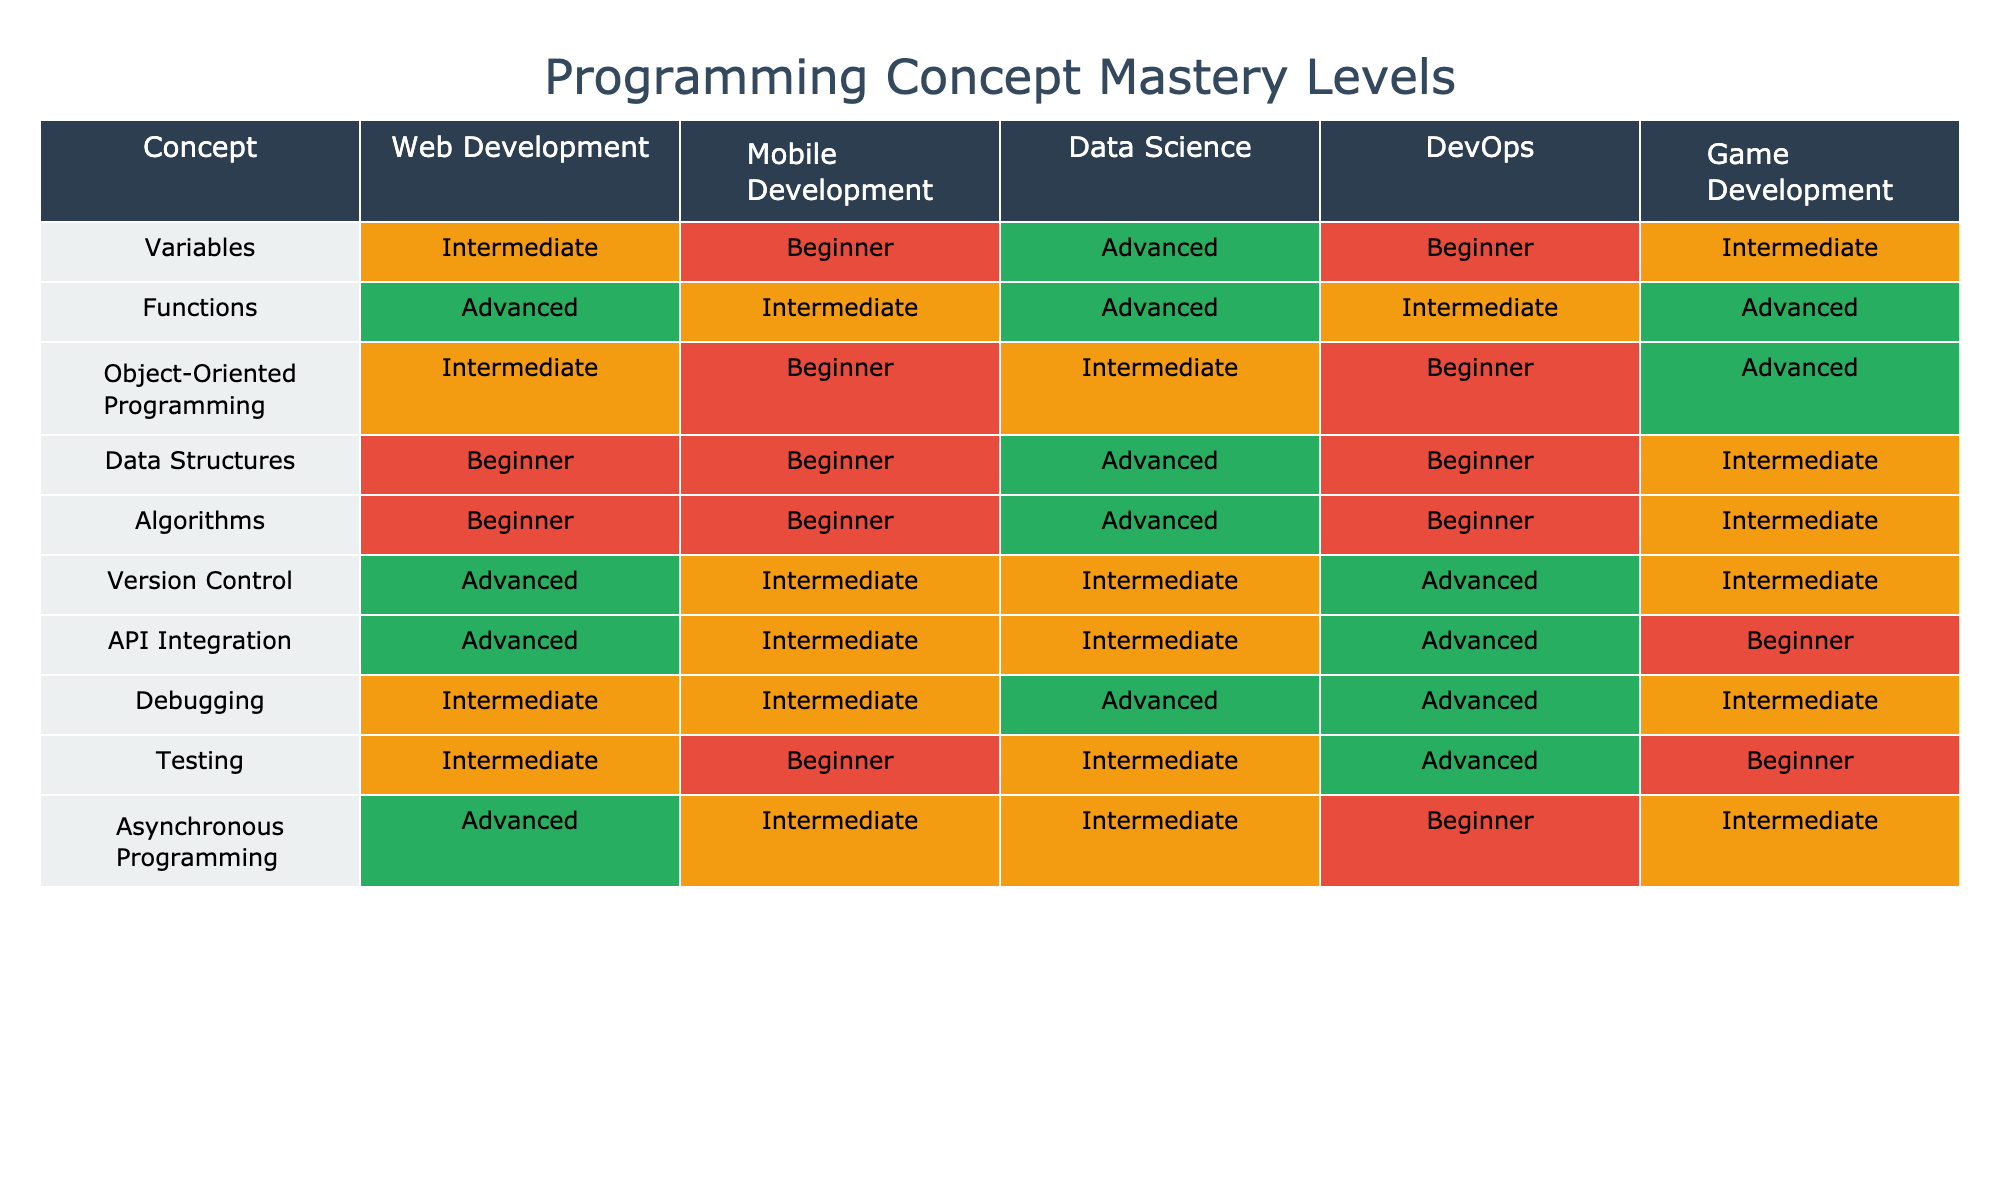What is the mastery level for Variables in Data Science? The table shows that for the "Variables" concept within the "Data Science" domain, the mastery level is "Advanced."
Answer: Advanced Which programming concept has the lowest mastery level in Mobile Development? By looking at the Mobile Development column, "Object-Oriented Programming," "Data Structures," and "Algorithms" are all rated as "Beginner," which is the lowest level.
Answer: Object-Oriented Programming, Data Structures, Algorithms How many concepts are rated as "Intermediate" in Game Development? In the Game Development row, I can count four occurrences of "Intermediate" in the concepts listed, specifically for Variables, Functions, Data Structures, and Debugging.
Answer: 4 Is API Integration rated higher in Web Development compared to DevOps? The table indicates that "API Integration" is rated as "Advanced" in Web Development and "Advanced" in DevOps as well, so they are equal.
Answer: Yes What is the average mastery level for Functions across all domains? Functions are rated as Advanced in Web Development, Intermediate in Mobile Development, Advanced in Data Science, Intermediate in DevOps, and Advanced in Game Development. Converting these to a numerical scale (Advanced = 3, Intermediate = 2, Beginner = 1), the average is (3 + 2 + 3 + 2 + 3) = 13, and divided by 5 results in an average of 2.6, which corresponds to Intermediate.
Answer: Intermediate Which concept has the highest mastery level in all domains combined? Observing the table, "Functions" and "Version Control" appear to have "Advanced," which is the highest level in Data Science, Web Development, and Game Development. Thus, they tie as the top concepts.
Answer: Functions, Version Control What is the mastery level difference for Debugging between Data Science and DevOps? Debugging is "Advanced" in Data Science and "Advanced" in DevOps, creating no difference; both are at the same mastery level.
Answer: No difference Count the number of concepts rated as "Beginner" in the Data Science domain. Looking at the Data Science column, I find "Data Structures," "Algorithms," and "Object-Oriented Programming" which are three concepts rated as "Beginner."
Answer: 3 Are there any concepts where the mastery level is "Advanced" across all domains? Checking each concept in the table, I see that there are no concepts rated "Advanced" in all domains; some are "Advanced" in some but not all.
Answer: No Which domain has the most concepts rated at the "Advanced" level? Evaluating the columns, Web Development has "Variables," "Functions," and "API Integration" rated as Advanced which counts to three concepts; Data Science has "Variables" and "Functions" for a total of two; DevOps has "Version Control" and "Debugging;" while Game Development and Mobile Development have fewer "Advanced" concepts. Thus, Web Development has the most Advanced concepts.
Answer: Web Development 